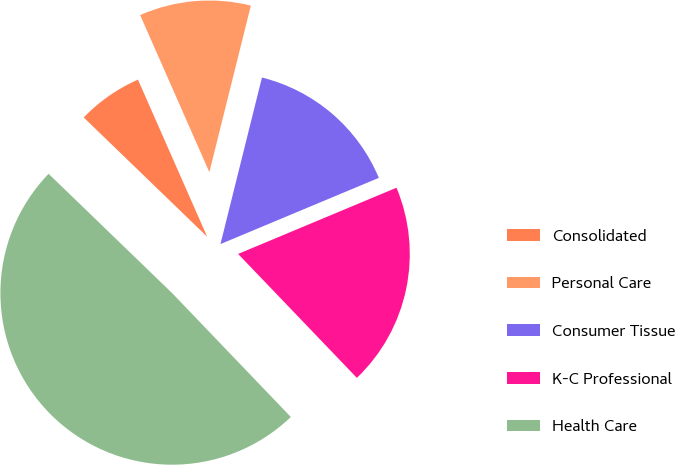Convert chart to OTSL. <chart><loc_0><loc_0><loc_500><loc_500><pie_chart><fcel>Consolidated<fcel>Personal Care<fcel>Consumer Tissue<fcel>K-C Professional<fcel>Health Care<nl><fcel>6.17%<fcel>10.49%<fcel>14.81%<fcel>19.14%<fcel>49.38%<nl></chart> 